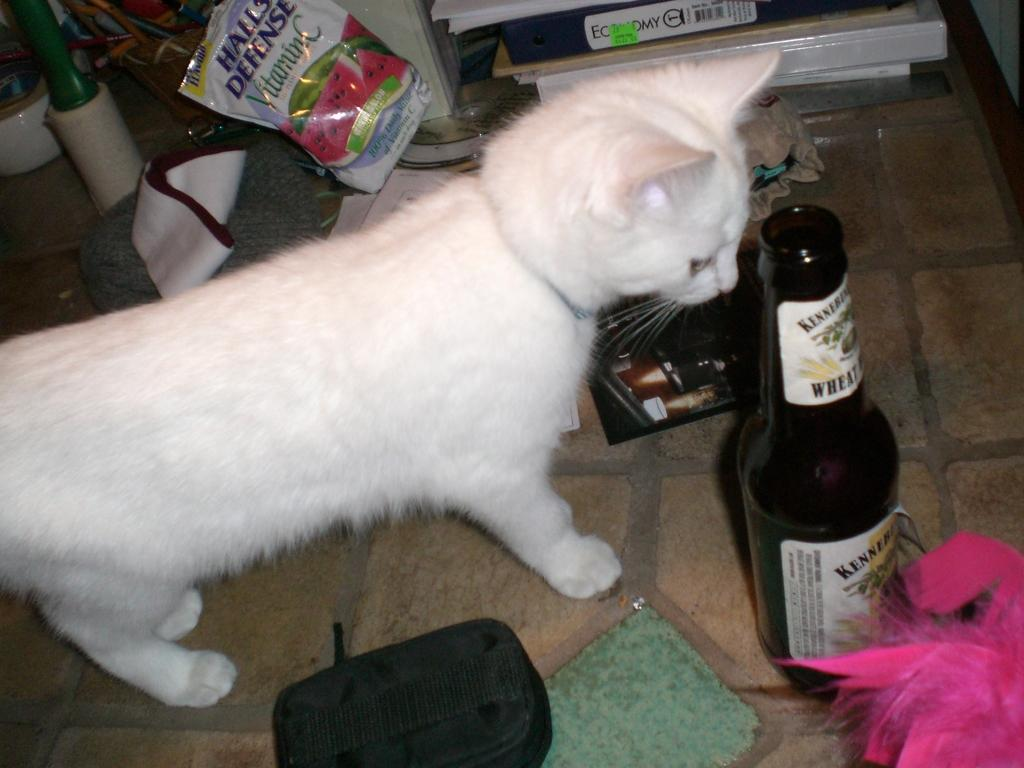What type of animal is in the image? There is a white cat in the image. What is the cat standing in front of? The cat is standing in front of a bottle. What can be seen around the cat? There are many items around the cat. What is visible behind the cat? There are files visible behind the cat. What type of rhythm does the cat create by walking on the wool in the image? There is no wool or walking cat in the image; it features a white cat standing in front of a bottle with files visible behind it. 